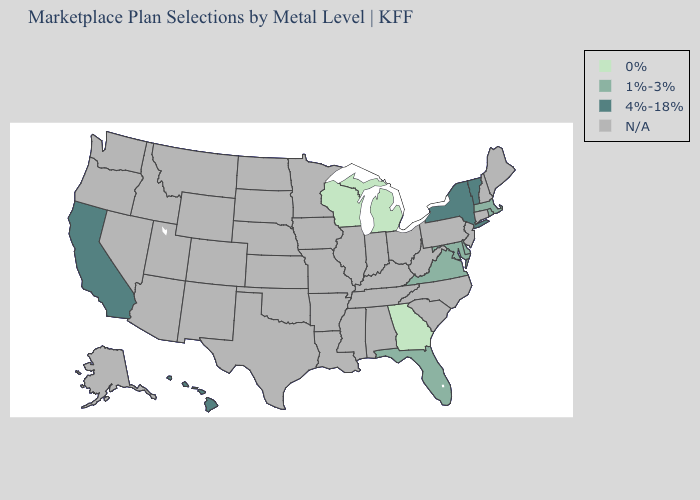Name the states that have a value in the range N/A?
Write a very short answer. Alabama, Alaska, Arizona, Arkansas, Colorado, Connecticut, Idaho, Illinois, Indiana, Iowa, Kansas, Kentucky, Louisiana, Maine, Minnesota, Mississippi, Missouri, Montana, Nebraska, Nevada, New Hampshire, New Jersey, New Mexico, North Carolina, North Dakota, Ohio, Oklahoma, Oregon, Pennsylvania, South Carolina, South Dakota, Tennessee, Texas, Utah, Washington, West Virginia, Wyoming. What is the value of New York?
Quick response, please. 4%-18%. What is the value of California?
Short answer required. 4%-18%. Name the states that have a value in the range N/A?
Keep it brief. Alabama, Alaska, Arizona, Arkansas, Colorado, Connecticut, Idaho, Illinois, Indiana, Iowa, Kansas, Kentucky, Louisiana, Maine, Minnesota, Mississippi, Missouri, Montana, Nebraska, Nevada, New Hampshire, New Jersey, New Mexico, North Carolina, North Dakota, Ohio, Oklahoma, Oregon, Pennsylvania, South Carolina, South Dakota, Tennessee, Texas, Utah, Washington, West Virginia, Wyoming. Name the states that have a value in the range N/A?
Quick response, please. Alabama, Alaska, Arizona, Arkansas, Colorado, Connecticut, Idaho, Illinois, Indiana, Iowa, Kansas, Kentucky, Louisiana, Maine, Minnesota, Mississippi, Missouri, Montana, Nebraska, Nevada, New Hampshire, New Jersey, New Mexico, North Carolina, North Dakota, Ohio, Oklahoma, Oregon, Pennsylvania, South Carolina, South Dakota, Tennessee, Texas, Utah, Washington, West Virginia, Wyoming. What is the highest value in the MidWest ?
Write a very short answer. 0%. Which states have the lowest value in the USA?
Quick response, please. Georgia, Michigan, Wisconsin. Which states have the lowest value in the MidWest?
Quick response, please. Michigan, Wisconsin. Name the states that have a value in the range 0%?
Keep it brief. Georgia, Michigan, Wisconsin. What is the value of Virginia?
Be succinct. 1%-3%. 